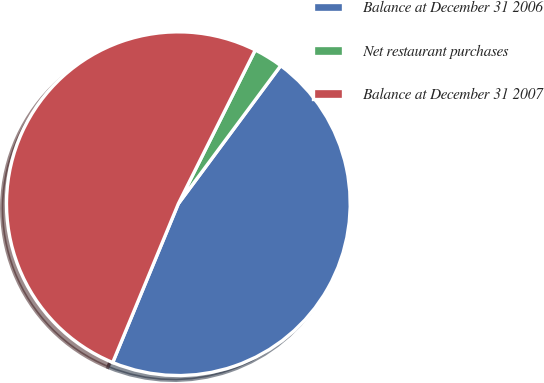<chart> <loc_0><loc_0><loc_500><loc_500><pie_chart><fcel>Balance at December 31 2006<fcel>Net restaurant purchases<fcel>Balance at December 31 2007<nl><fcel>46.08%<fcel>2.77%<fcel>51.14%<nl></chart> 